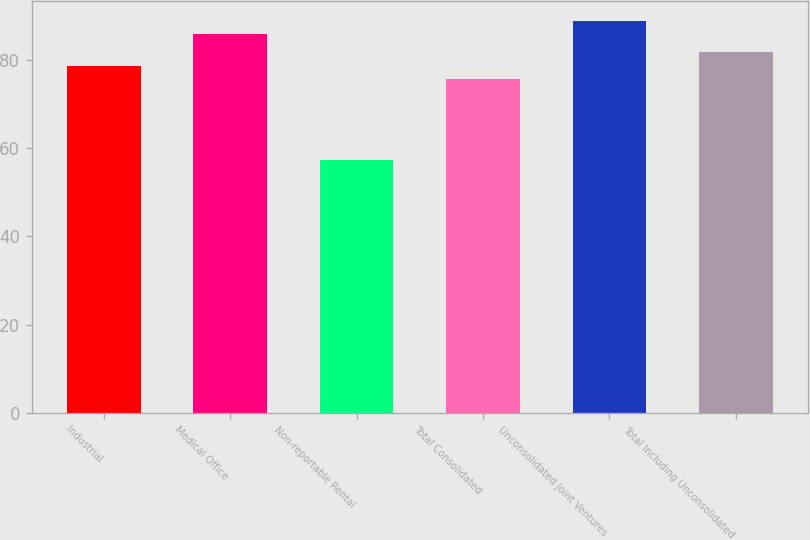Convert chart. <chart><loc_0><loc_0><loc_500><loc_500><bar_chart><fcel>Industrial<fcel>Medical Office<fcel>Non-reportable Rental<fcel>Total Consolidated<fcel>Unconsolidated Joint Ventures<fcel>Total Including Unconsolidated<nl><fcel>78.73<fcel>85.8<fcel>57.3<fcel>75.7<fcel>88.83<fcel>81.76<nl></chart> 